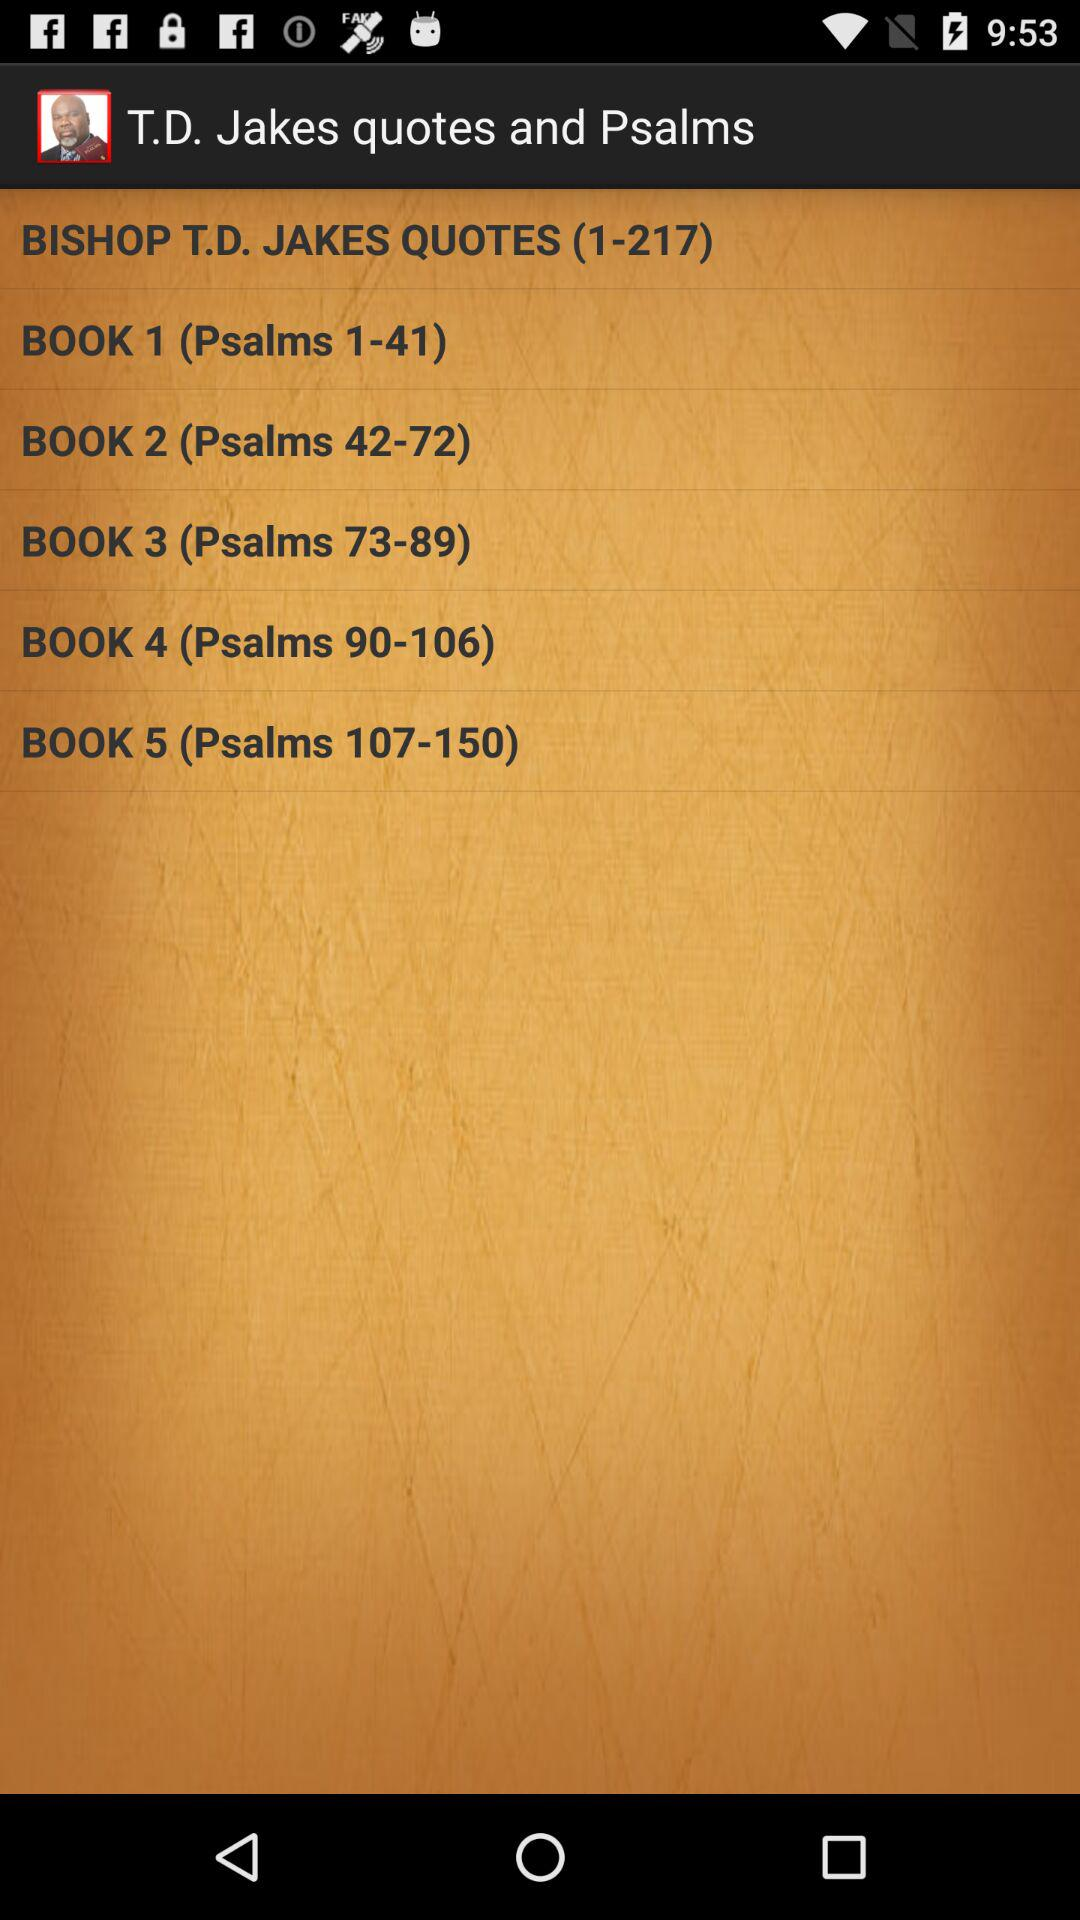What is the name of the application? The name of the application is "T.D. Jakes quotes and Psalms". 